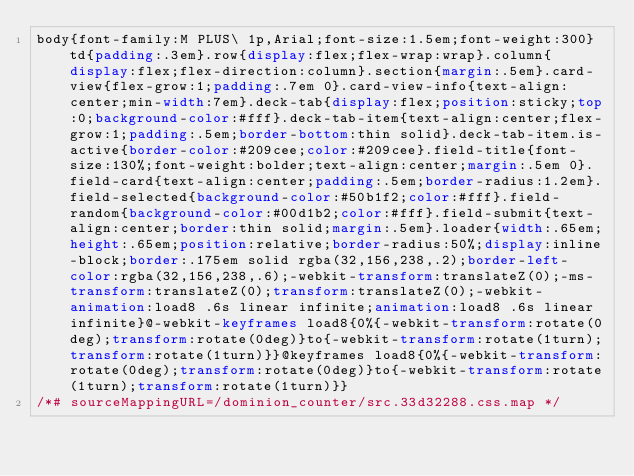<code> <loc_0><loc_0><loc_500><loc_500><_CSS_>body{font-family:M PLUS\ 1p,Arial;font-size:1.5em;font-weight:300}td{padding:.3em}.row{display:flex;flex-wrap:wrap}.column{display:flex;flex-direction:column}.section{margin:.5em}.card-view{flex-grow:1;padding:.7em 0}.card-view-info{text-align:center;min-width:7em}.deck-tab{display:flex;position:sticky;top:0;background-color:#fff}.deck-tab-item{text-align:center;flex-grow:1;padding:.5em;border-bottom:thin solid}.deck-tab-item.is-active{border-color:#209cee;color:#209cee}.field-title{font-size:130%;font-weight:bolder;text-align:center;margin:.5em 0}.field-card{text-align:center;padding:.5em;border-radius:1.2em}.field-selected{background-color:#50b1f2;color:#fff}.field-random{background-color:#00d1b2;color:#fff}.field-submit{text-align:center;border:thin solid;margin:.5em}.loader{width:.65em;height:.65em;position:relative;border-radius:50%;display:inline-block;border:.175em solid rgba(32,156,238,.2);border-left-color:rgba(32,156,238,.6);-webkit-transform:translateZ(0);-ms-transform:translateZ(0);transform:translateZ(0);-webkit-animation:load8 .6s linear infinite;animation:load8 .6s linear infinite}@-webkit-keyframes load8{0%{-webkit-transform:rotate(0deg);transform:rotate(0deg)}to{-webkit-transform:rotate(1turn);transform:rotate(1turn)}}@keyframes load8{0%{-webkit-transform:rotate(0deg);transform:rotate(0deg)}to{-webkit-transform:rotate(1turn);transform:rotate(1turn)}}
/*# sourceMappingURL=/dominion_counter/src.33d32288.css.map */</code> 